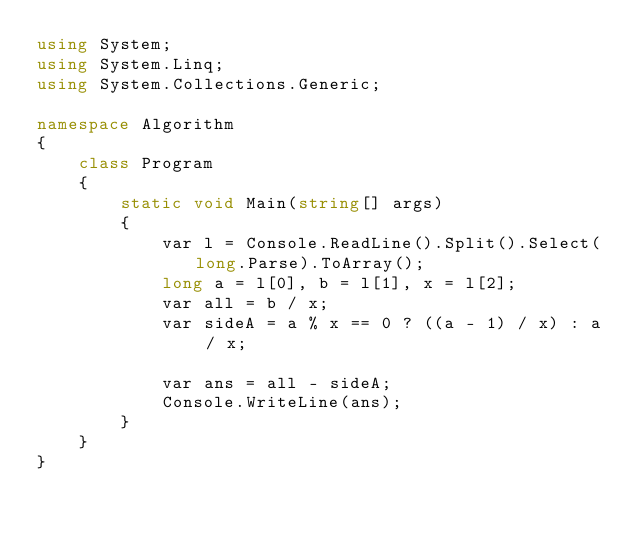<code> <loc_0><loc_0><loc_500><loc_500><_C#_>using System;
using System.Linq;
using System.Collections.Generic;

namespace Algorithm
{
    class Program
    {
        static void Main(string[] args)
        {
            var l = Console.ReadLine().Split().Select(long.Parse).ToArray();
            long a = l[0], b = l[1], x = l[2];
            var all = b / x;
            var sideA = a % x == 0 ? ((a - 1) / x) : a / x;

            var ans = all - sideA;
            Console.WriteLine(ans);
        }
    }
}
</code> 